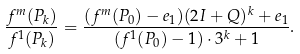<formula> <loc_0><loc_0><loc_500><loc_500>\frac { f ^ { m } ( P _ { k } ) } { f ^ { 1 } ( P _ { k } ) } = \frac { ( f ^ { m } ( P _ { 0 } ) - e _ { 1 } ) ( 2 I + Q ) ^ { k } + e _ { 1 } } { ( f ^ { 1 } ( P _ { 0 } ) - 1 ) \cdot 3 ^ { k } + 1 } .</formula> 